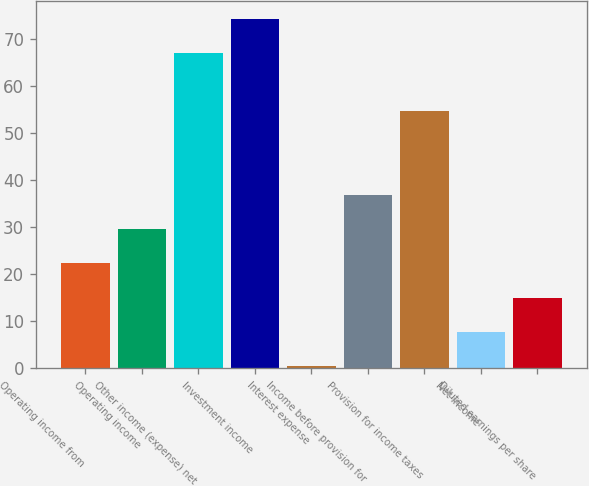Convert chart to OTSL. <chart><loc_0><loc_0><loc_500><loc_500><bar_chart><fcel>Operating income from<fcel>Operating income<fcel>Other income (expense) net<fcel>Investment income<fcel>Interest expense<fcel>Income before provision for<fcel>Provision for income taxes<fcel>Net income<fcel>Diluted earnings per share<nl><fcel>22.3<fcel>29.6<fcel>66.9<fcel>74.2<fcel>0.4<fcel>36.9<fcel>54.6<fcel>7.7<fcel>15<nl></chart> 